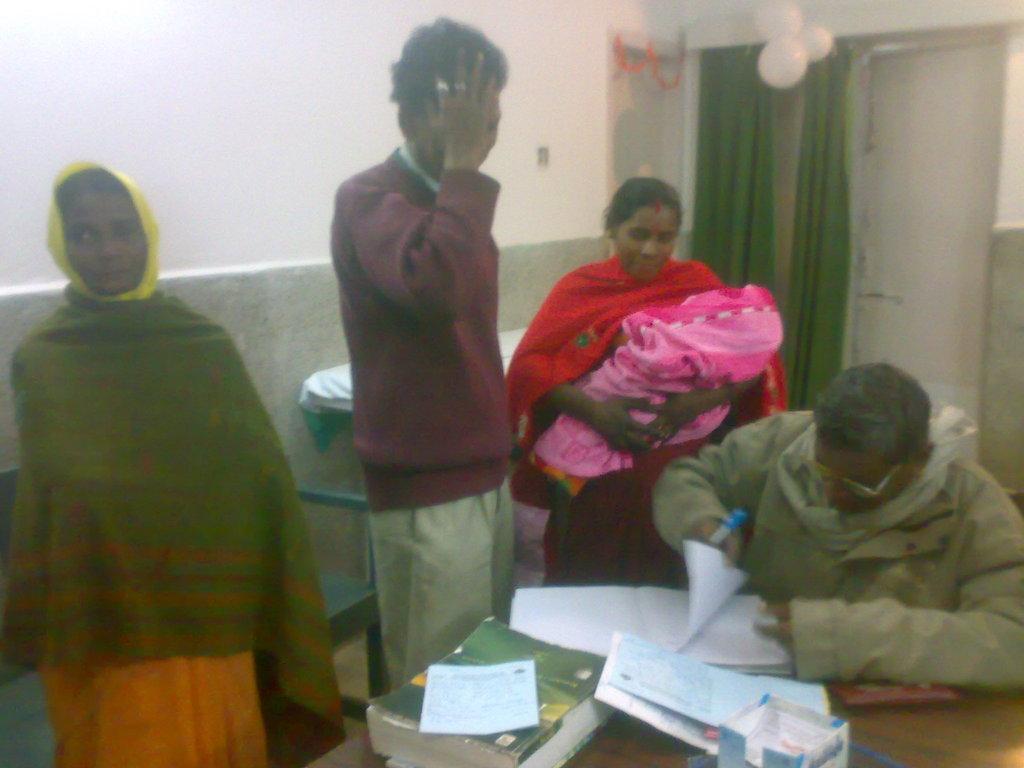Describe this image in one or two sentences. In this picture there is a man who is wearing sweater, shirt and trouser. Beside him there is a woman who is holding a baby. On the right there is a man who is sitting near to the table. On the table I can see the book, papers, box and other objects. On the left there is a woman who is standing near to the bench. In the back I can see the doors, green cloth and balloons. 